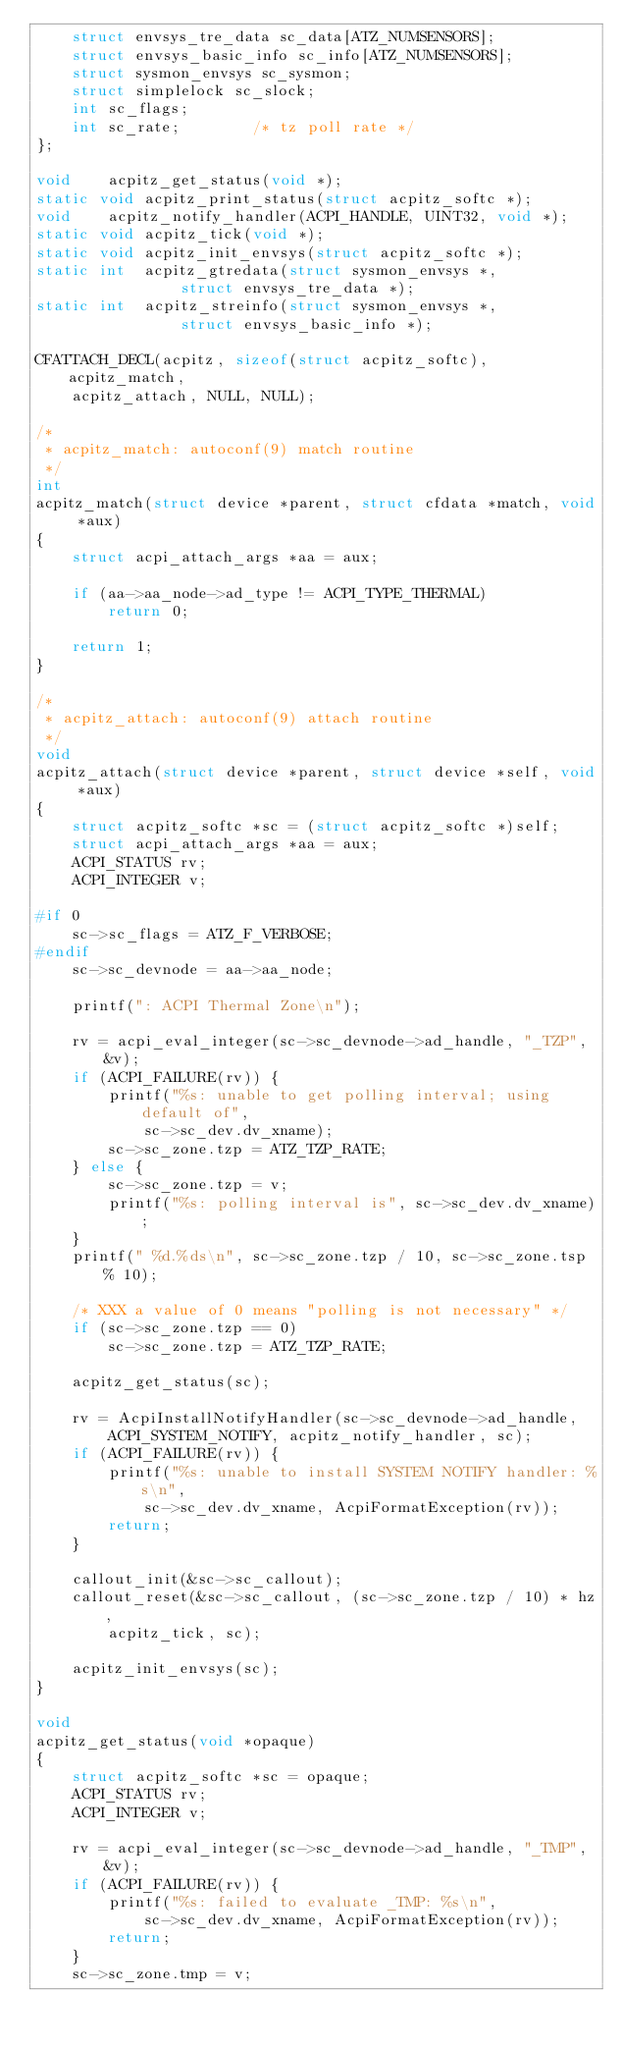<code> <loc_0><loc_0><loc_500><loc_500><_C_>	struct envsys_tre_data sc_data[ATZ_NUMSENSORS];
	struct envsys_basic_info sc_info[ATZ_NUMSENSORS];
	struct sysmon_envsys sc_sysmon;
	struct simplelock sc_slock;
	int sc_flags;
	int sc_rate;		/* tz poll rate */
};

void	acpitz_get_status(void *);
static void	acpitz_print_status(struct acpitz_softc *);
void	acpitz_notify_handler(ACPI_HANDLE, UINT32, void *);
static void	acpitz_tick(void *);
static void	acpitz_init_envsys(struct acpitz_softc *);
static int	acpitz_gtredata(struct sysmon_envsys *,
				struct envsys_tre_data *);
static int	acpitz_streinfo(struct sysmon_envsys *,
				struct envsys_basic_info *);

CFATTACH_DECL(acpitz, sizeof(struct acpitz_softc), acpitz_match,
    acpitz_attach, NULL, NULL);

/*
 * acpitz_match: autoconf(9) match routine
 */
int
acpitz_match(struct device *parent, struct cfdata *match, void *aux)
{
	struct acpi_attach_args *aa = aux;

	if (aa->aa_node->ad_type != ACPI_TYPE_THERMAL)
		return 0;

	return 1;
}

/*
 * acpitz_attach: autoconf(9) attach routine
 */
void
acpitz_attach(struct device *parent, struct device *self, void *aux)
{
	struct acpitz_softc *sc = (struct acpitz_softc *)self;
	struct acpi_attach_args *aa = aux;
	ACPI_STATUS rv;
	ACPI_INTEGER v;

#if 0
	sc->sc_flags = ATZ_F_VERBOSE;
#endif
	sc->sc_devnode = aa->aa_node;

	printf(": ACPI Thermal Zone\n");

	rv = acpi_eval_integer(sc->sc_devnode->ad_handle, "_TZP", &v);
	if (ACPI_FAILURE(rv)) {
		printf("%s: unable to get polling interval; using default of",
		    sc->sc_dev.dv_xname);
		sc->sc_zone.tzp = ATZ_TZP_RATE;
	} else {
		sc->sc_zone.tzp = v;
		printf("%s: polling interval is", sc->sc_dev.dv_xname);
	}
	printf(" %d.%ds\n", sc->sc_zone.tzp / 10, sc->sc_zone.tsp % 10);

	/* XXX a value of 0 means "polling is not necessary" */
	if (sc->sc_zone.tzp == 0)
		sc->sc_zone.tzp = ATZ_TZP_RATE;
	
	acpitz_get_status(sc);

	rv = AcpiInstallNotifyHandler(sc->sc_devnode->ad_handle,
	    ACPI_SYSTEM_NOTIFY, acpitz_notify_handler, sc);
	if (ACPI_FAILURE(rv)) {
		printf("%s: unable to install SYSTEM NOTIFY handler: %s\n",
		    sc->sc_dev.dv_xname, AcpiFormatException(rv));
		return;
	}

	callout_init(&sc->sc_callout);
	callout_reset(&sc->sc_callout, (sc->sc_zone.tzp / 10) * hz,
	    acpitz_tick, sc);

	acpitz_init_envsys(sc);
}

void
acpitz_get_status(void *opaque)
{
	struct acpitz_softc *sc = opaque;
	ACPI_STATUS rv;
	ACPI_INTEGER v;

	rv = acpi_eval_integer(sc->sc_devnode->ad_handle, "_TMP", &v);
	if (ACPI_FAILURE(rv)) {
		printf("%s: failed to evaluate _TMP: %s\n",
		    sc->sc_dev.dv_xname, AcpiFormatException(rv));
		return;
	}
	sc->sc_zone.tmp = v;
</code> 